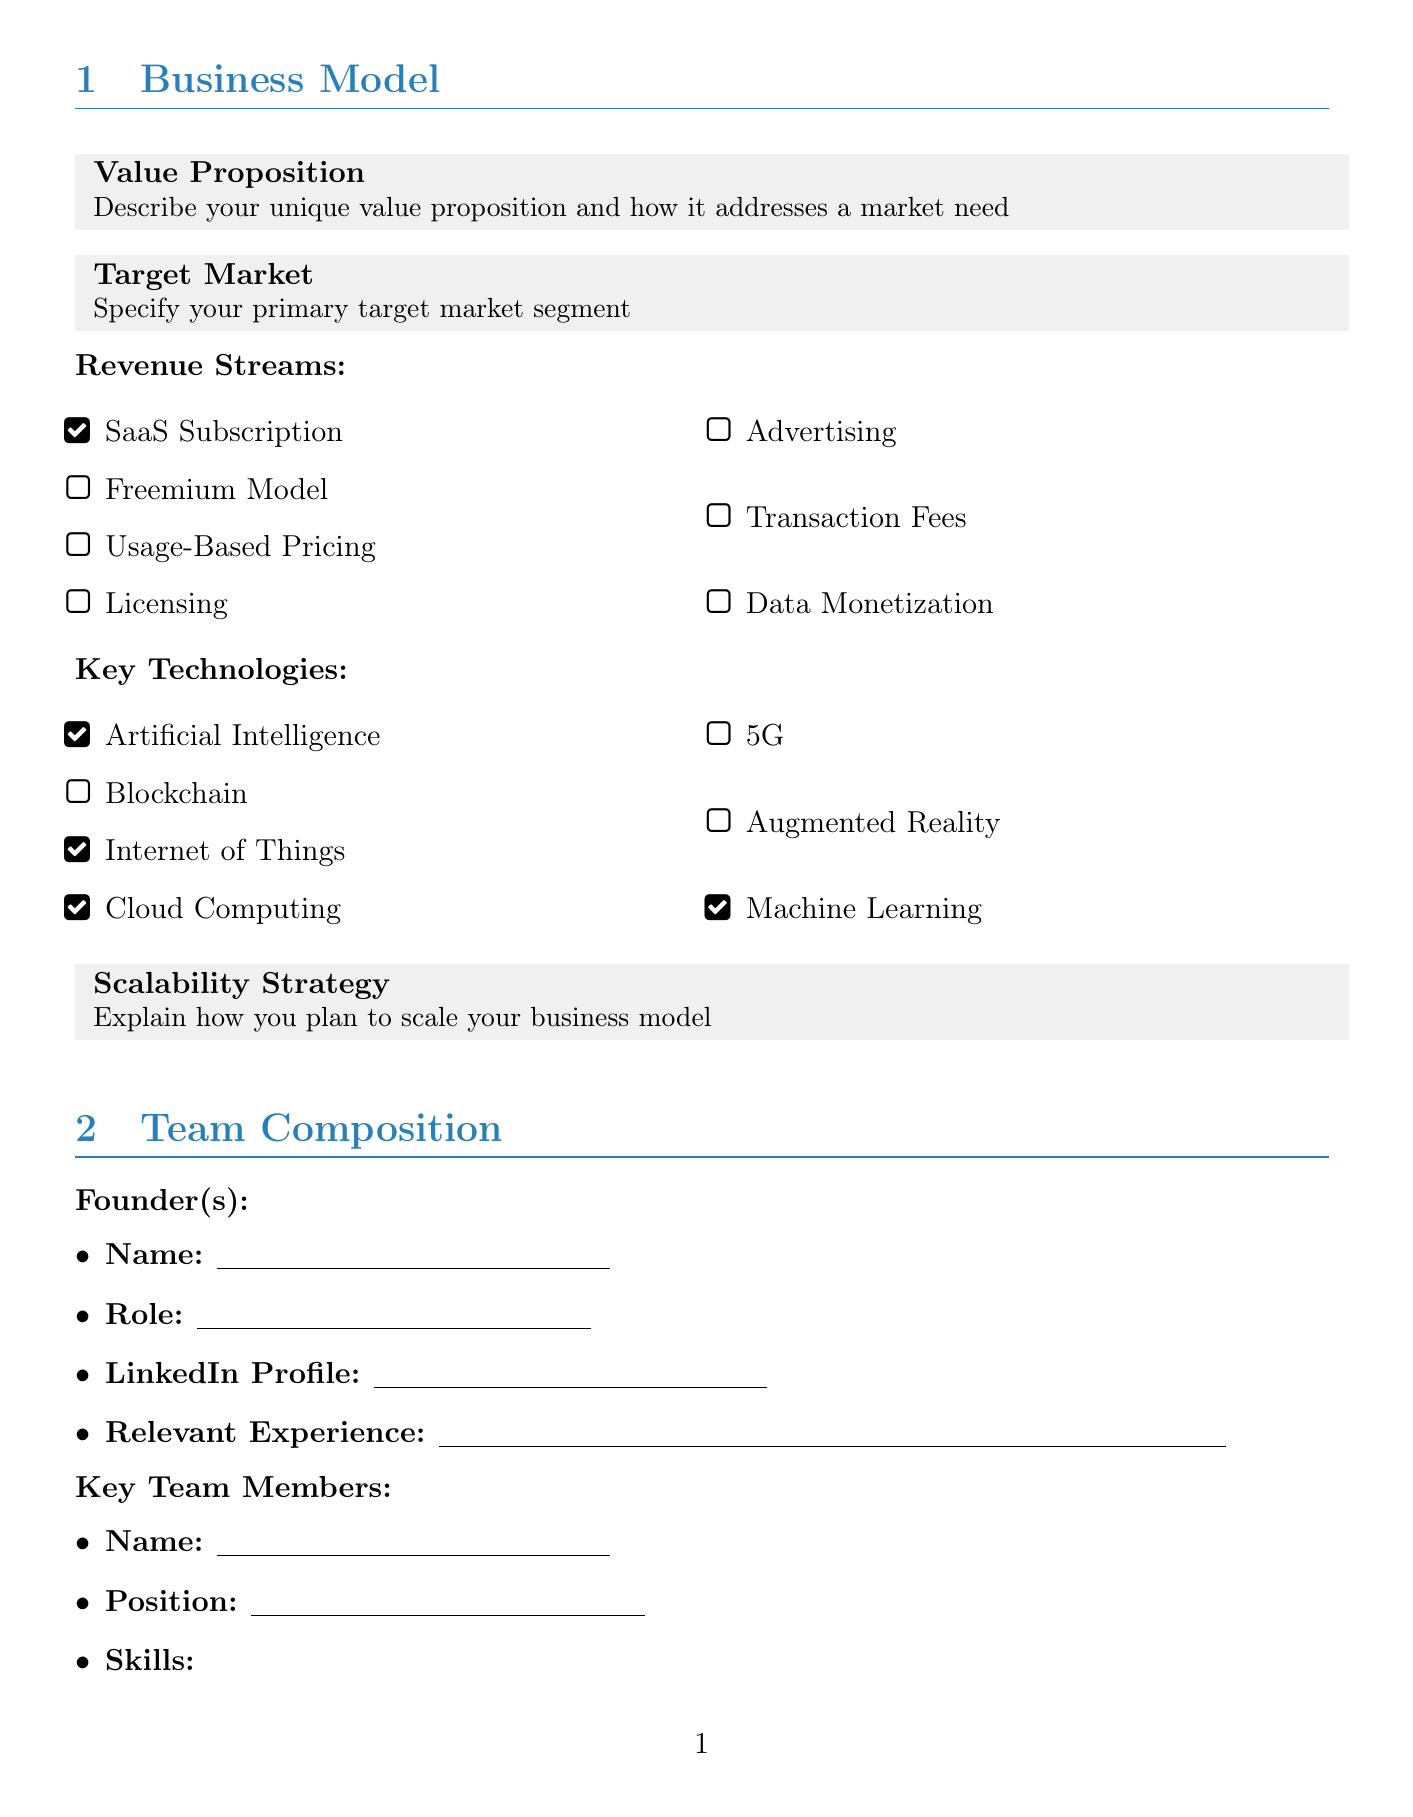What is the unique value proposition? The unique value proposition addresses a specific market need described in the document.
Answer: Describe your unique value proposition and how it addresses a market need What is the primary target market segment? The primary target market segment should be clearly specified in the document.
Answer: Specify your primary target market segment How many funding rounds have been detailed? The number of funding rounds can be counted based on the repeater section in the document.
Answer: As many as entered in the Funding Rounds section What is the total amount raised in USD? This amount is specified in the Total Funding Raised field of the document.
Answer: Enter the total amount raised in USD What key technology is mentioned the most? Identifying the technology that appears most frequently in the Key Technologies section.
Answer: Depends on user input in the multiselect options What are the plans for expanding the team? The plans for expanding the team are described in the Hiring Plans section.
Answer: Describe your plans for expanding the team in the next 6-12 months Who is the lead investor? The name of the lead investor is entered in the Funding Rounds section.
Answer: Enter the name of the lead investor What is the monthly burn rate? The monthly burn rate is specified in the Burn Rate field in the document.
Answer: Enter monthly burn rate in USD What cybersecurity measures are outlined? Cybersecurity measures are discussed in the Cybersecurity Measures section of the document.
Answer: Describe the security protocols and measures implemented to protect user data and intellectual property 